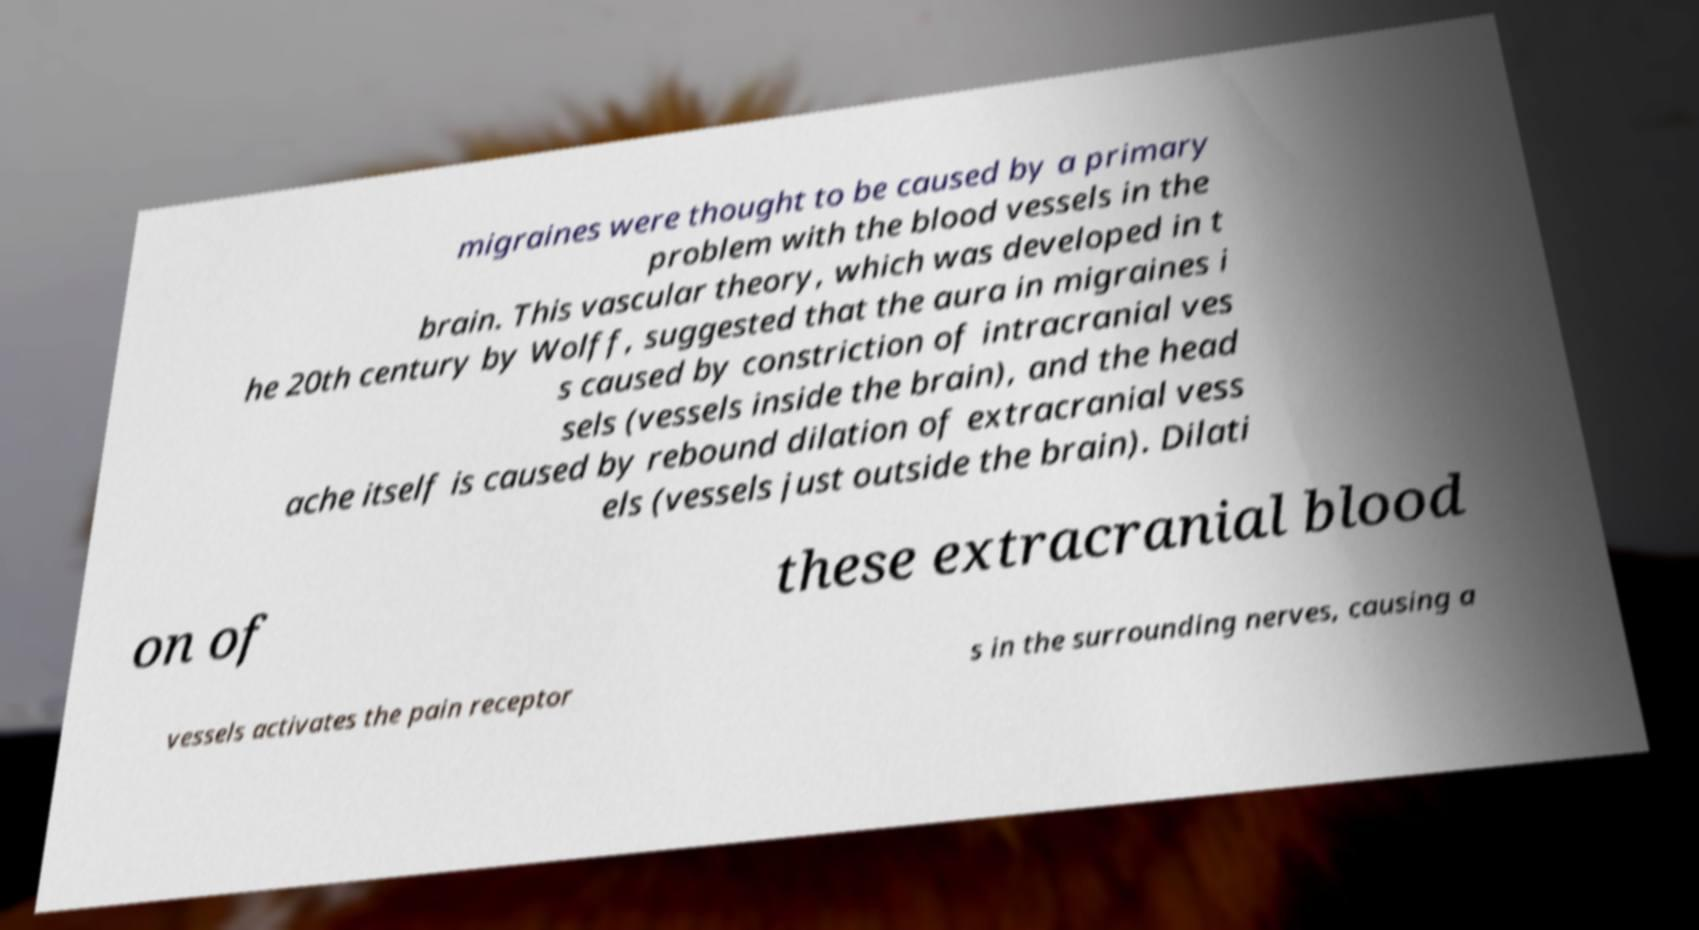I need the written content from this picture converted into text. Can you do that? migraines were thought to be caused by a primary problem with the blood vessels in the brain. This vascular theory, which was developed in t he 20th century by Wolff, suggested that the aura in migraines i s caused by constriction of intracranial ves sels (vessels inside the brain), and the head ache itself is caused by rebound dilation of extracranial vess els (vessels just outside the brain). Dilati on of these extracranial blood vessels activates the pain receptor s in the surrounding nerves, causing a 